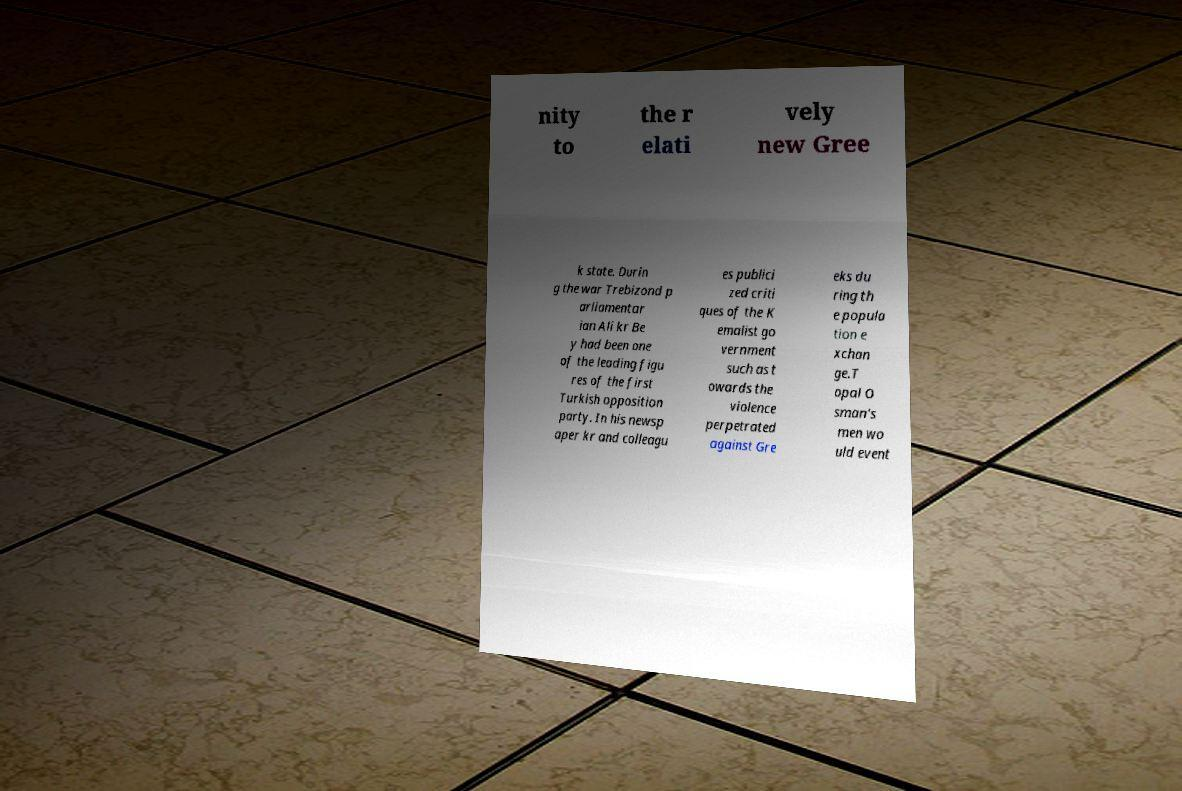Could you extract and type out the text from this image? nity to the r elati vely new Gree k state. Durin g the war Trebizond p arliamentar ian Ali kr Be y had been one of the leading figu res of the first Turkish opposition party. In his newsp aper kr and colleagu es publici zed criti ques of the K emalist go vernment such as t owards the violence perpetrated against Gre eks du ring th e popula tion e xchan ge.T opal O sman's men wo uld event 